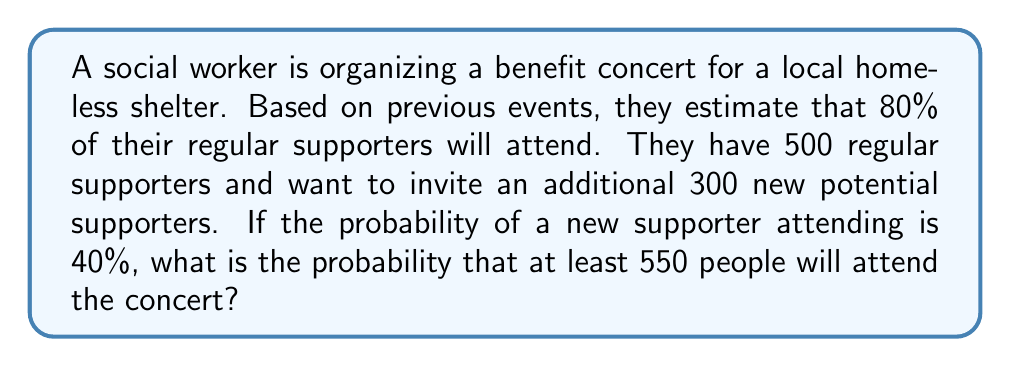Give your solution to this math problem. Let's approach this step-by-step:

1) First, we need to calculate the expected number of attendees from each group:

   Regular supporters: $500 \times 0.80 = 400$
   New potential supporters: $300 \times 0.40 = 120$

   Expected total attendees: $400 + 120 = 520$

2) We can model this situation using a binomial distribution for each group:

   Regular supporters: $X \sim B(500, 0.80)$
   New supporters: $Y \sim B(300, 0.40)$

3) The total number of attendees $Z = X + Y$

4) We need to find $P(Z \geq 550)$

5) The exact calculation of this probability is complex due to the sum of two binomial distributions. However, we can use the Central Limit Theorem to approximate this with a normal distribution:

   $Z \sim N(\mu, \sigma^2)$

   Where:
   $$\mu = 500 \times 0.80 + 300 \times 0.40 = 520$$
   $$\sigma^2 = 500 \times 0.80 \times 0.20 + 300 \times 0.40 \times 0.60 = 152$$

6) Now we can standardize:

   $$z = \frac{550 - 520}{\sqrt{152}} \approx 2.43$$

7) Using a standard normal table or calculator, we can find:

   $P(Z \geq 550) = P(z \geq 2.43) \approx 1 - 0.9925 = 0.0075$

Therefore, the probability of at least 550 people attending is approximately 0.0075 or 0.75%.
Answer: The probability that at least 550 people will attend the concert is approximately 0.0075 or 0.75%. 